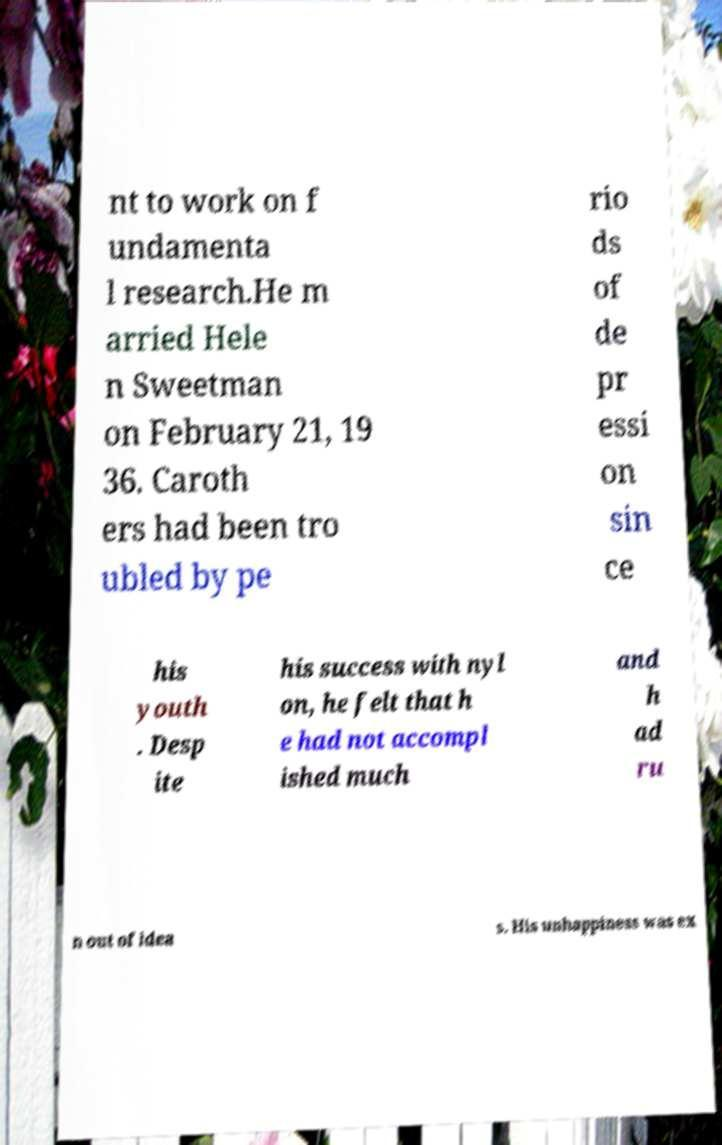For documentation purposes, I need the text within this image transcribed. Could you provide that? nt to work on f undamenta l research.He m arried Hele n Sweetman on February 21, 19 36. Caroth ers had been tro ubled by pe rio ds of de pr essi on sin ce his youth . Desp ite his success with nyl on, he felt that h e had not accompl ished much and h ad ru n out of idea s. His unhappiness was ex 